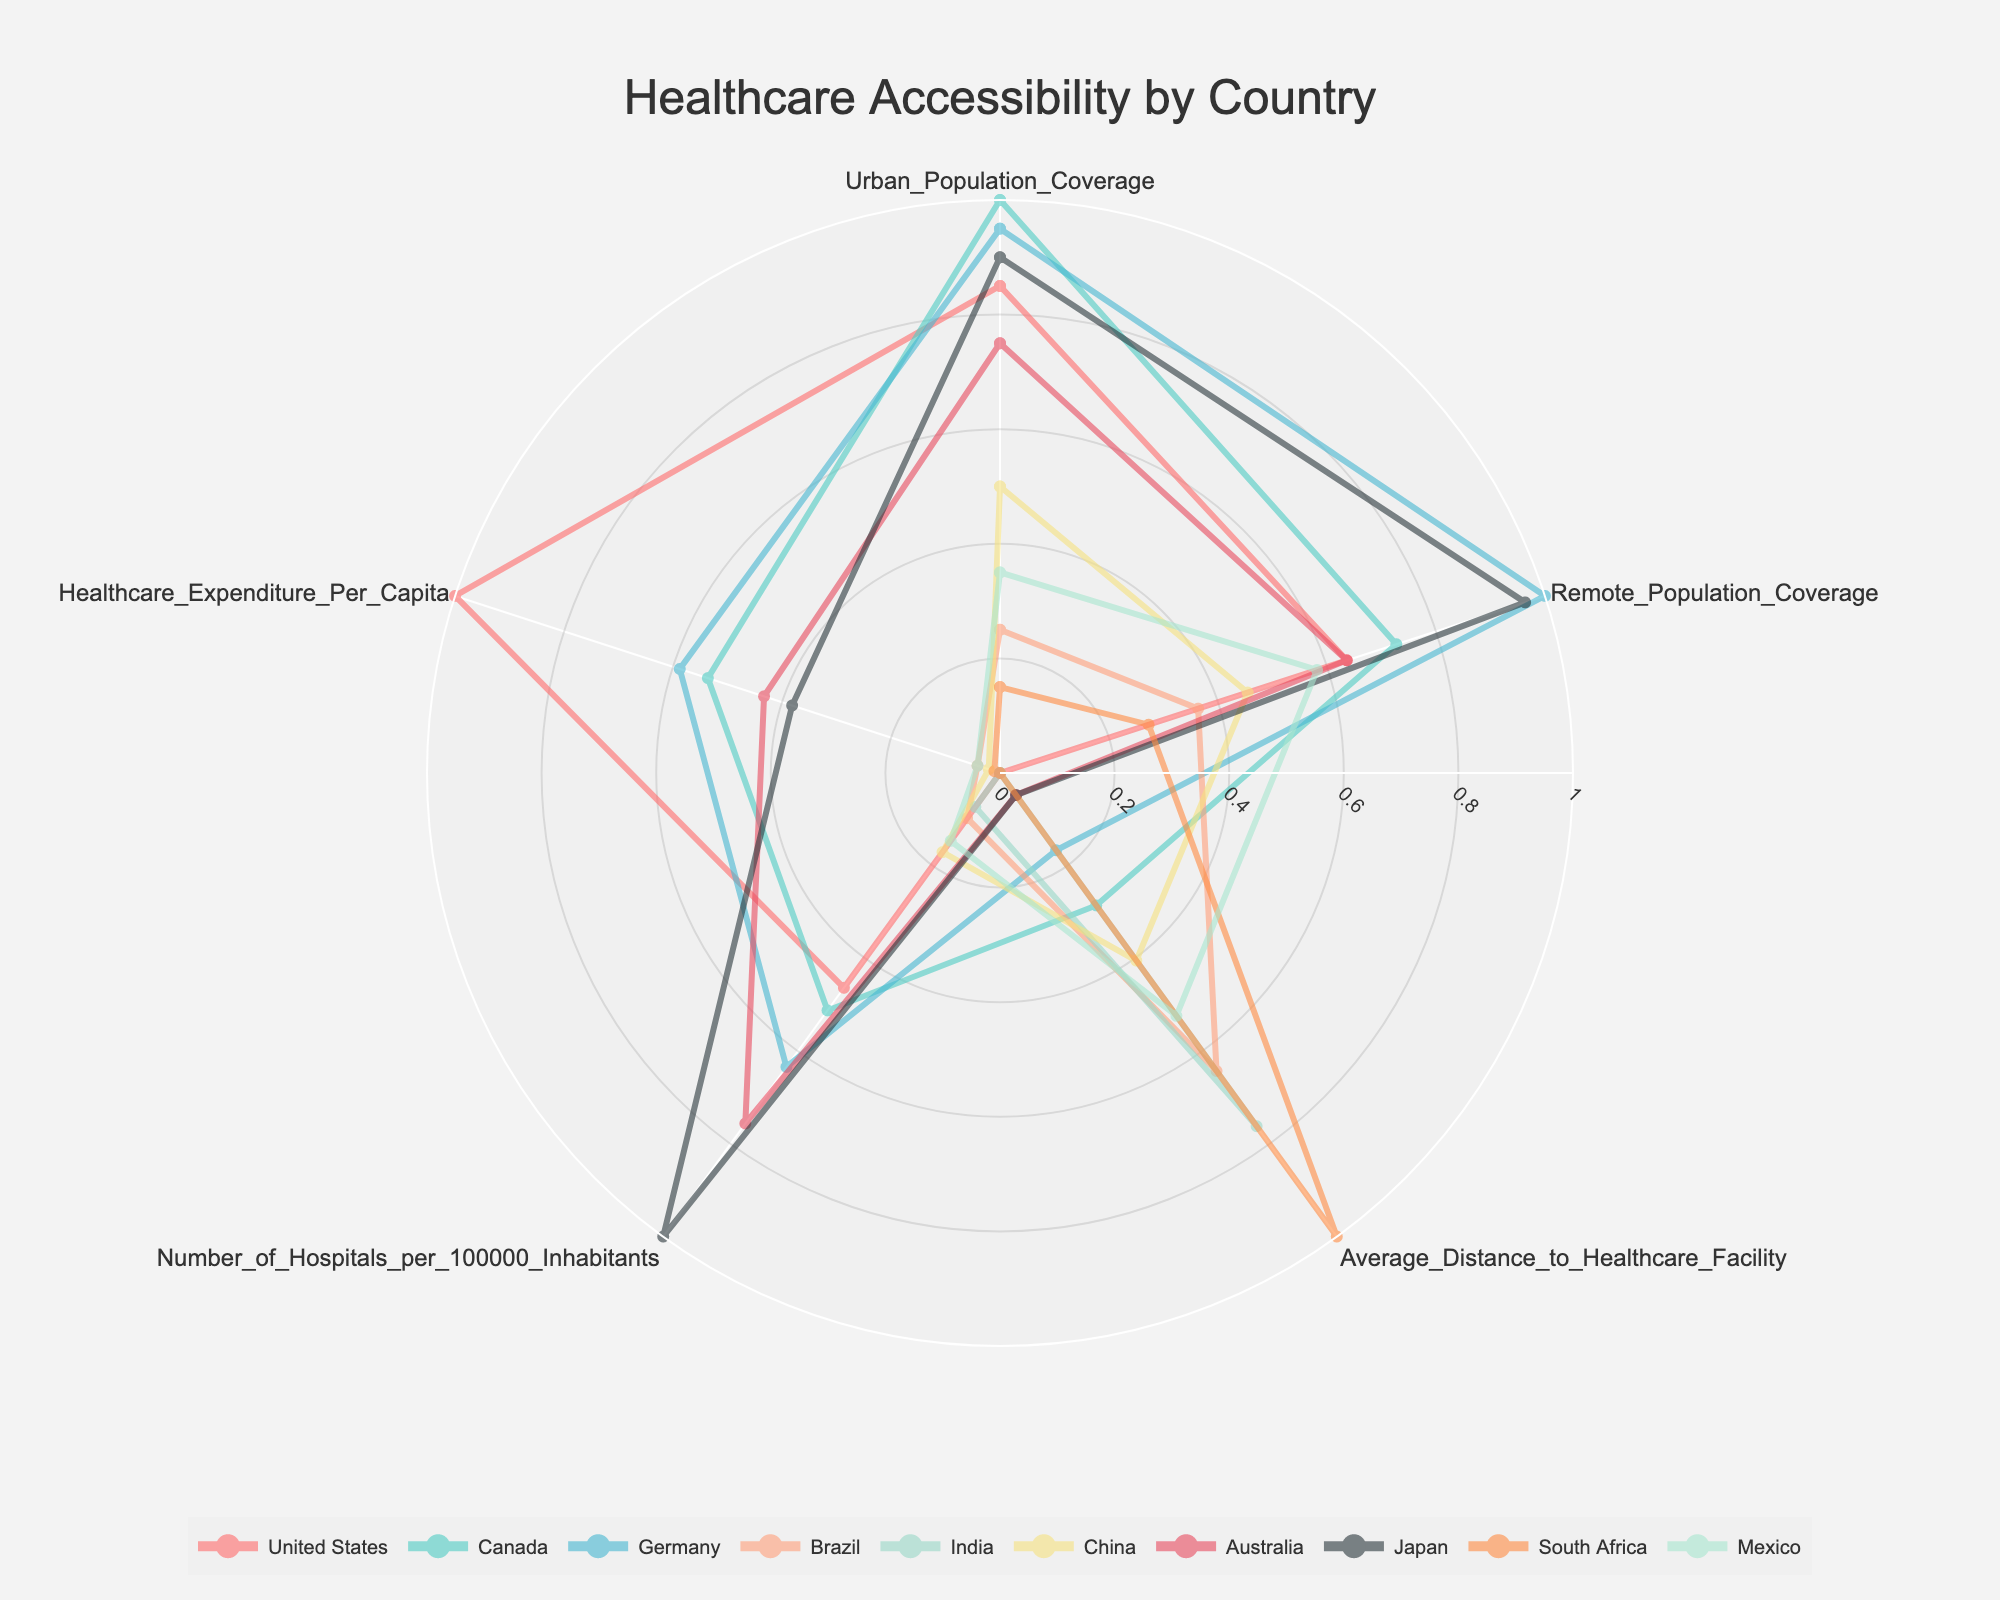What is the title of the radar chart? The title of the radar chart is located at the top center of the image. It describes what the chart is about.
Answer: Healthcare Accessibility by Country Which country has the highest coverage for remote populations? To determine this, we look at the point on the chart representing the remote population coverage (one of the categories) and see which country extends furthest along this axis.
Answer: Germany What is the average number of hospitals per 100,000 inhabitants across all countries? To find the average number of hospitals per 100,000 inhabitants, sum the values for this category from each country and divide by the number of countries. Sum: (2.8 + 3 + 3.5 + 1.3 + 1.2 + 1.6 + 4 + 5 + 0.9 + 1.5) = 24.8. There are 10 countries, so 24.8 / 10 = 2.48
Answer: 2.48 Which country has a lower healthcare expenditure per capita, China or India? Look at the points on the radar chart representing healthcare expenditure per capita for China and India and identify which one is lower.
Answer: India What are the two countries with the furthest distance to healthcare facilities? Look at the points representing the average distance to healthcare facilities and find the two countries which extend furthest along this axis.
Answer: South Africa and Brazil Does Japan have better urban population coverage or remote population coverage? Compare the points representing urban and remote population coverages for Japan and see which one extends further along its axis.
Answer: Urban population coverage What is the difference in healthcare expenditure per capita between the United States and Canada? Subtract Canada's healthcare expenditure per capita from that of the United States. The values are 10500 for the U.S. and 6000 for Canada. So, 10500 - 6000 = 4500
Answer: 4500 Which country has the least number of hospitals per 100,000 inhabitants? On the radar chart, identify the country which marks the least along the axis for the number of hospitals per 100,000 inhabitants.
Answer: South Africa How does Brazil’s urban population coverage compare to India’s urban population coverage? Look at the points on the chart representing urban population coverage and see if Brazil’s point is higher, lower, or equal compared to India's point.
Answer: Higher What is the range of average distances to healthcare facilities observed in the chart? Find the minimum and maximum values of the average distance to healthcare facilities and then compute the range by subtracting the minimum value from the maximum value. The minimum is 8 (United States) and the maximum is 50 (South Africa), so the range is 50 - 8 = 42
Answer: 42 